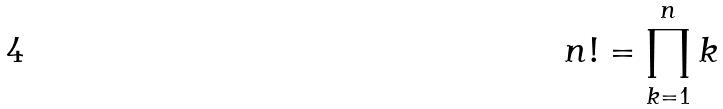<formula> <loc_0><loc_0><loc_500><loc_500>n ! = \prod _ { k = 1 } ^ { n } k</formula> 